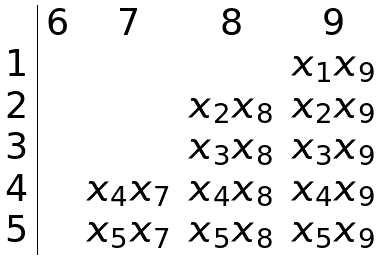<formula> <loc_0><loc_0><loc_500><loc_500>\begin{array} { c | c c c c } & 6 & 7 & 8 & 9 \\ 1 & & & & x _ { 1 } x _ { 9 } \\ 2 & & & x _ { 2 } x _ { 8 } & x _ { 2 } x _ { 9 } \\ 3 & & & x _ { 3 } x _ { 8 } & x _ { 3 } x _ { 9 } \\ 4 & & x _ { 4 } x _ { 7 } & x _ { 4 } x _ { 8 } & x _ { 4 } x _ { 9 } \\ 5 & & x _ { 5 } x _ { 7 } & x _ { 5 } x _ { 8 } & x _ { 5 } x _ { 9 } \\ \end{array}</formula> 